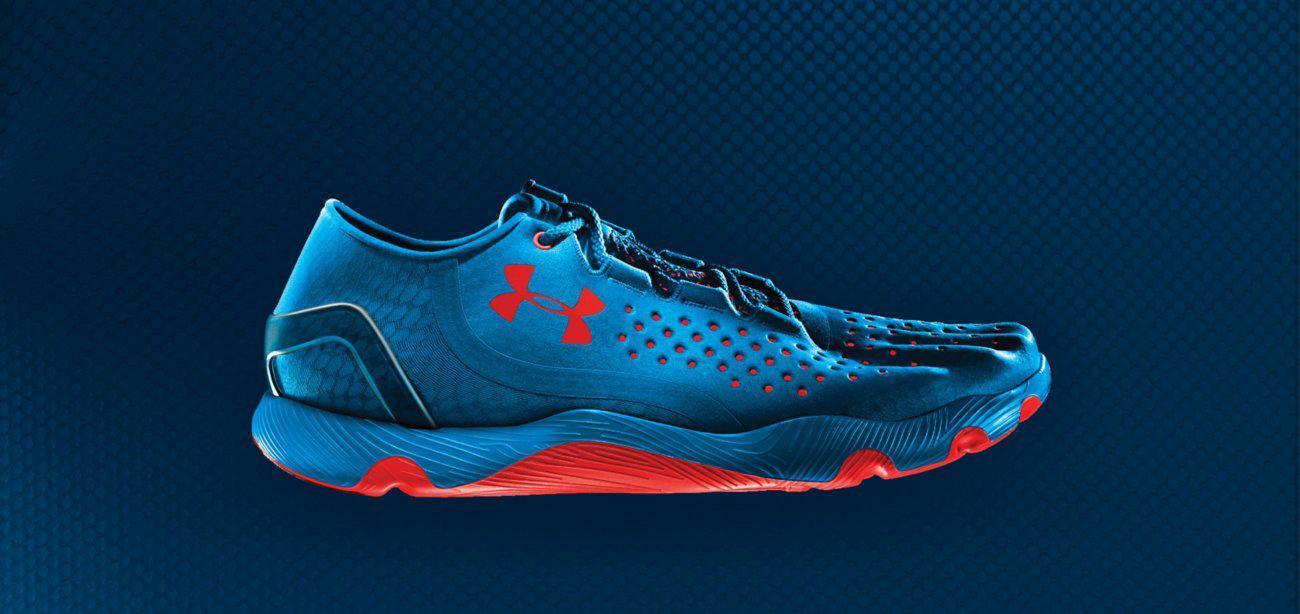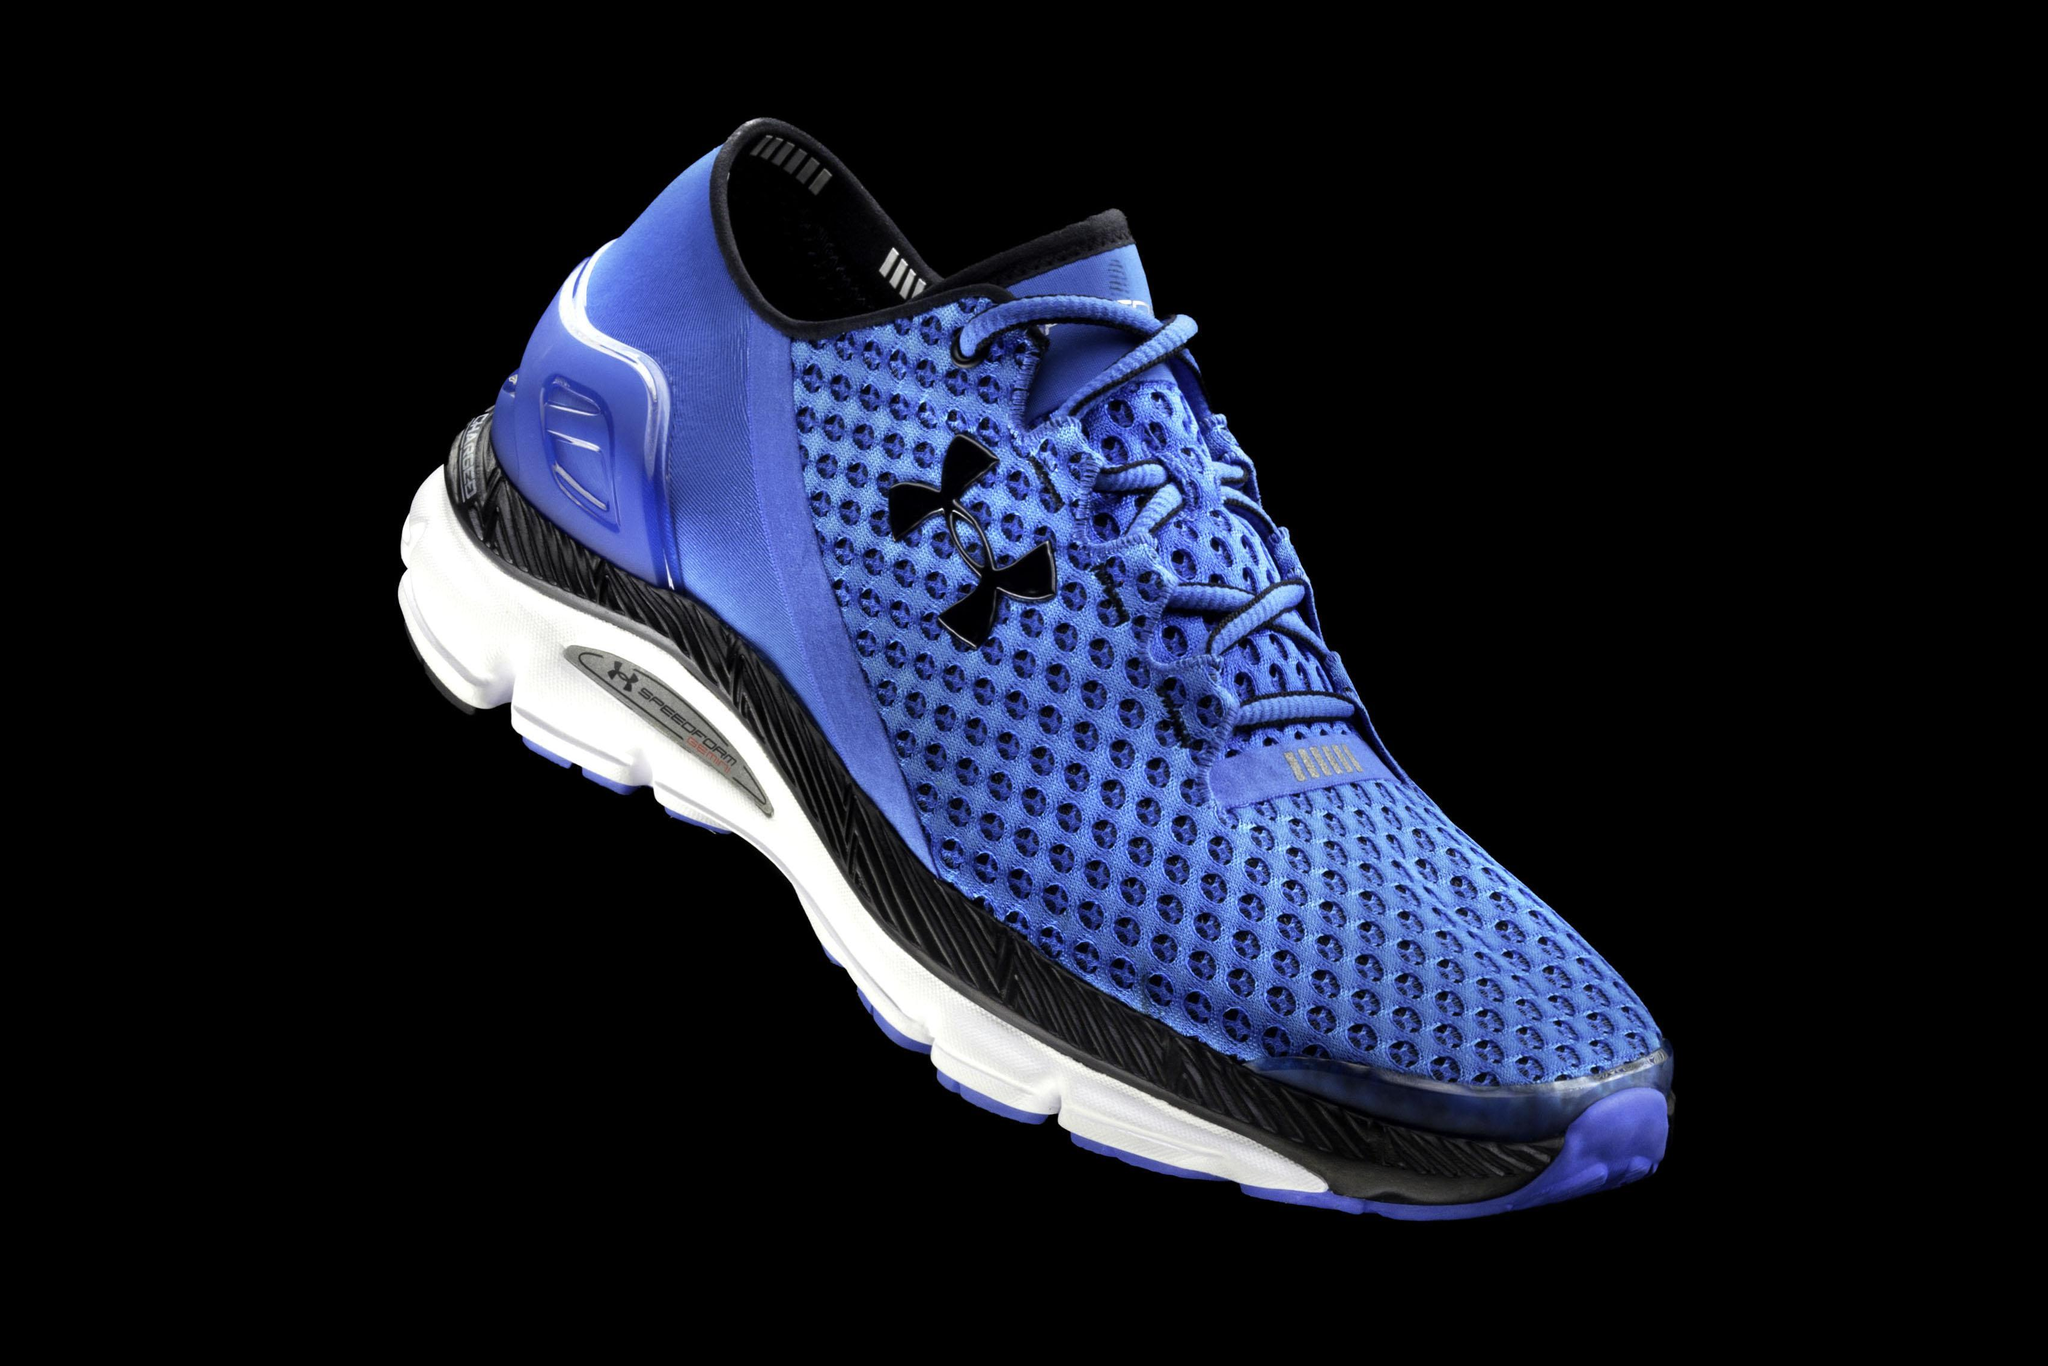The first image is the image on the left, the second image is the image on the right. Assess this claim about the two images: "Three or more of the shoes are at least partially green.". Correct or not? Answer yes or no. No. 